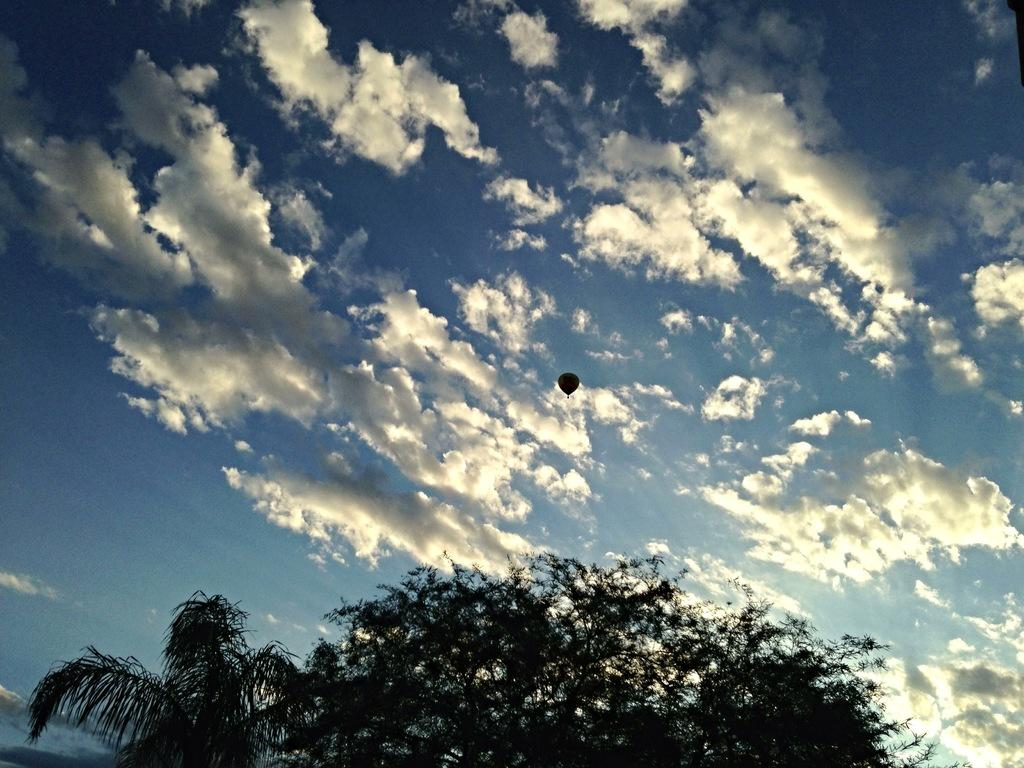What can be seen in the sky in the image? The sky with clouds is visible in the image. What is the main object in the sky? There is a hot air balloon in the image. What type of vegetation is present at the bottom of the image? Branches of trees are present at the bottom of the image. What part of the trees can be seen in the image? Leaves are visible in the image. What type of pear is hanging from the branches in the image? There are no pears present in the image; only branches and leaves can be seen. 